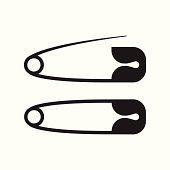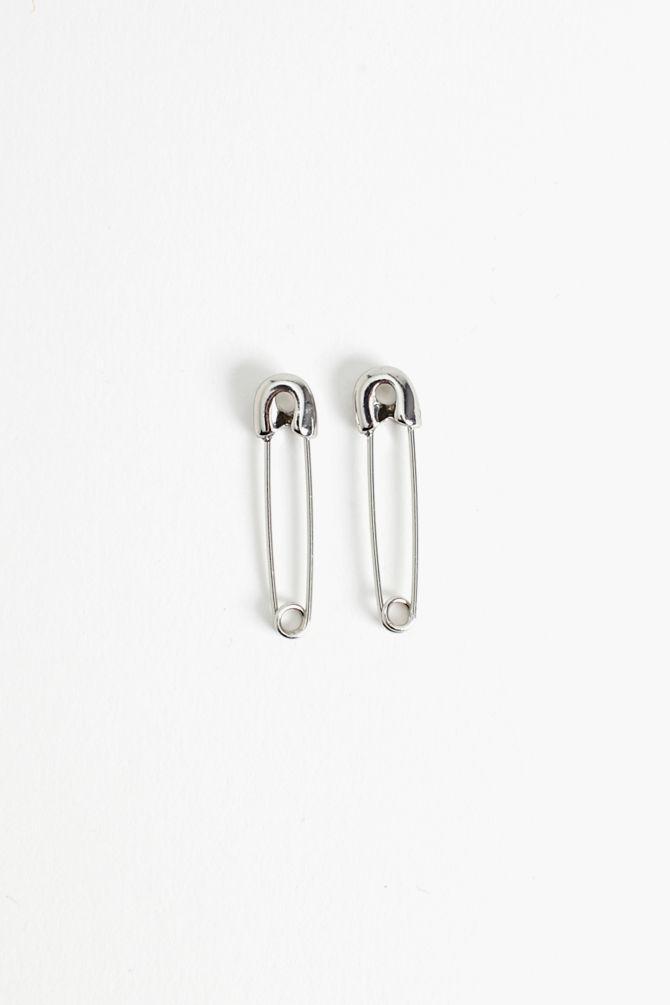The first image is the image on the left, the second image is the image on the right. Given the left and right images, does the statement "There's at least one open safety pin." hold true? Answer yes or no. Yes. The first image is the image on the left, the second image is the image on the right. Evaluate the accuracy of this statement regarding the images: "There are four safety pins.". Is it true? Answer yes or no. Yes. 